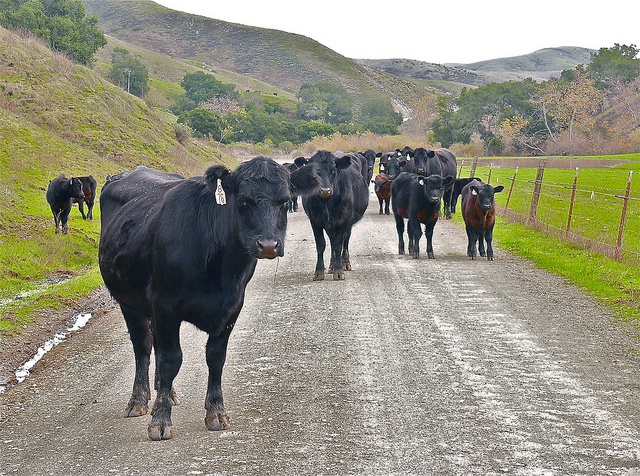Describe the objects in this image and their specific colors. I can see cow in gray, black, and darkblue tones, cow in gray and black tones, cow in gray, black, and lightgray tones, cow in gray, black, and maroon tones, and cow in gray, black, and darkgray tones in this image. 